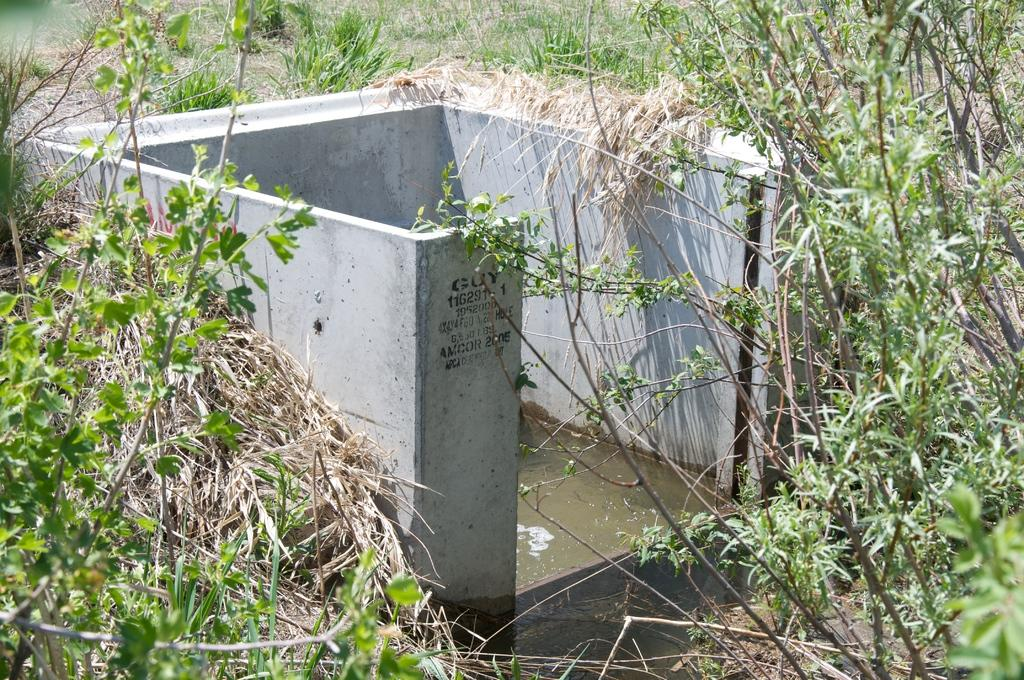What type of walls are present in the image? There are cement walls in the image. What can be seen in the image besides the walls? Water is visible in the image. What is located in the background of the image? There is a group of plants in the background of the image. How does the zephyr affect the plants in the image? There is no mention of a zephyr in the image, so it cannot be determined how it would affect the plants. 